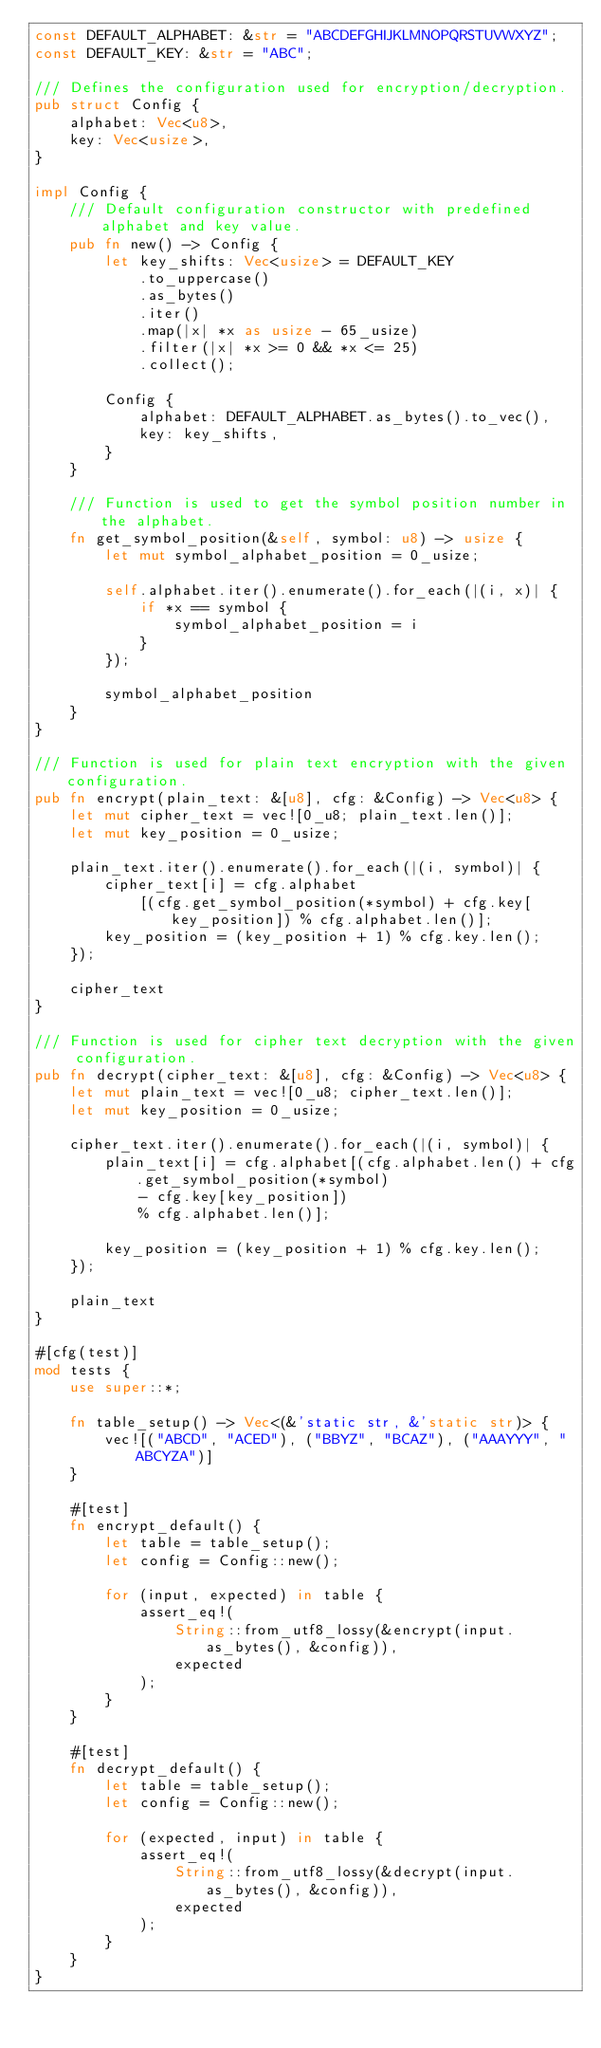<code> <loc_0><loc_0><loc_500><loc_500><_Rust_>const DEFAULT_ALPHABET: &str = "ABCDEFGHIJKLMNOPQRSTUVWXYZ";
const DEFAULT_KEY: &str = "ABC";

/// Defines the configuration used for encryption/decryption.
pub struct Config {
    alphabet: Vec<u8>,
    key: Vec<usize>,
}

impl Config {
    /// Default configuration constructor with predefined alphabet and key value.
    pub fn new() -> Config {
        let key_shifts: Vec<usize> = DEFAULT_KEY
            .to_uppercase()
            .as_bytes()
            .iter()
            .map(|x| *x as usize - 65_usize)
            .filter(|x| *x >= 0 && *x <= 25)
            .collect();

        Config {
            alphabet: DEFAULT_ALPHABET.as_bytes().to_vec(),
            key: key_shifts,
        }
    }

    /// Function is used to get the symbol position number in the alphabet.
    fn get_symbol_position(&self, symbol: u8) -> usize {
        let mut symbol_alphabet_position = 0_usize;

        self.alphabet.iter().enumerate().for_each(|(i, x)| {
            if *x == symbol {
                symbol_alphabet_position = i
            }
        });

        symbol_alphabet_position
    }
}

/// Function is used for plain text encryption with the given configuration.
pub fn encrypt(plain_text: &[u8], cfg: &Config) -> Vec<u8> {
    let mut cipher_text = vec![0_u8; plain_text.len()];
    let mut key_position = 0_usize;

    plain_text.iter().enumerate().for_each(|(i, symbol)| {
        cipher_text[i] = cfg.alphabet
            [(cfg.get_symbol_position(*symbol) + cfg.key[key_position]) % cfg.alphabet.len()];
        key_position = (key_position + 1) % cfg.key.len();
    });

    cipher_text
}

/// Function is used for cipher text decryption with the given configuration.
pub fn decrypt(cipher_text: &[u8], cfg: &Config) -> Vec<u8> {
    let mut plain_text = vec![0_u8; cipher_text.len()];
    let mut key_position = 0_usize;

    cipher_text.iter().enumerate().for_each(|(i, symbol)| {
        plain_text[i] = cfg.alphabet[(cfg.alphabet.len() + cfg.get_symbol_position(*symbol)
            - cfg.key[key_position])
            % cfg.alphabet.len()];

        key_position = (key_position + 1) % cfg.key.len();
    });

    plain_text
}

#[cfg(test)]
mod tests {
    use super::*;

    fn table_setup() -> Vec<(&'static str, &'static str)> {
        vec![("ABCD", "ACED"), ("BBYZ", "BCAZ"), ("AAAYYY", "ABCYZA")]
    }

    #[test]
    fn encrypt_default() {
        let table = table_setup();
        let config = Config::new();

        for (input, expected) in table {
            assert_eq!(
                String::from_utf8_lossy(&encrypt(input.as_bytes(), &config)),
                expected
            );
        }
    }

    #[test]
    fn decrypt_default() {
        let table = table_setup();
        let config = Config::new();

        for (expected, input) in table {
            assert_eq!(
                String::from_utf8_lossy(&decrypt(input.as_bytes(), &config)),
                expected
            );
        }
    }
}
</code> 